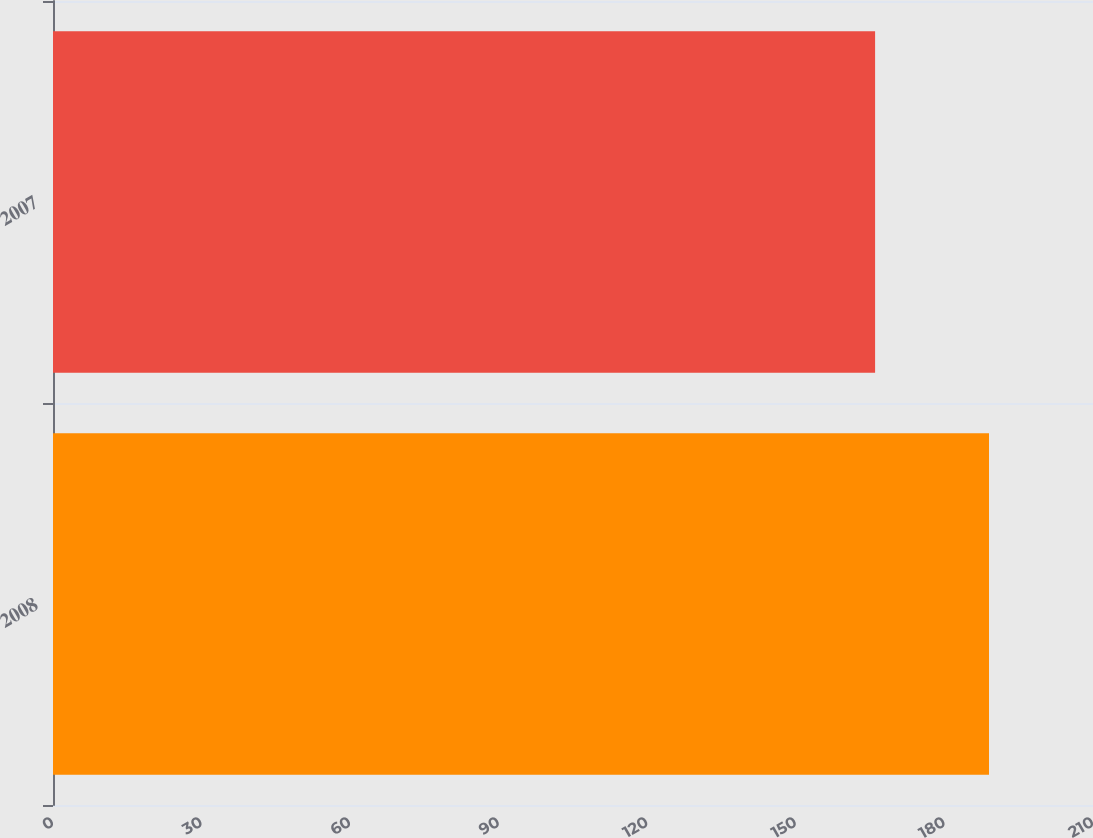Convert chart to OTSL. <chart><loc_0><loc_0><loc_500><loc_500><bar_chart><fcel>2008<fcel>2007<nl><fcel>189<fcel>166<nl></chart> 